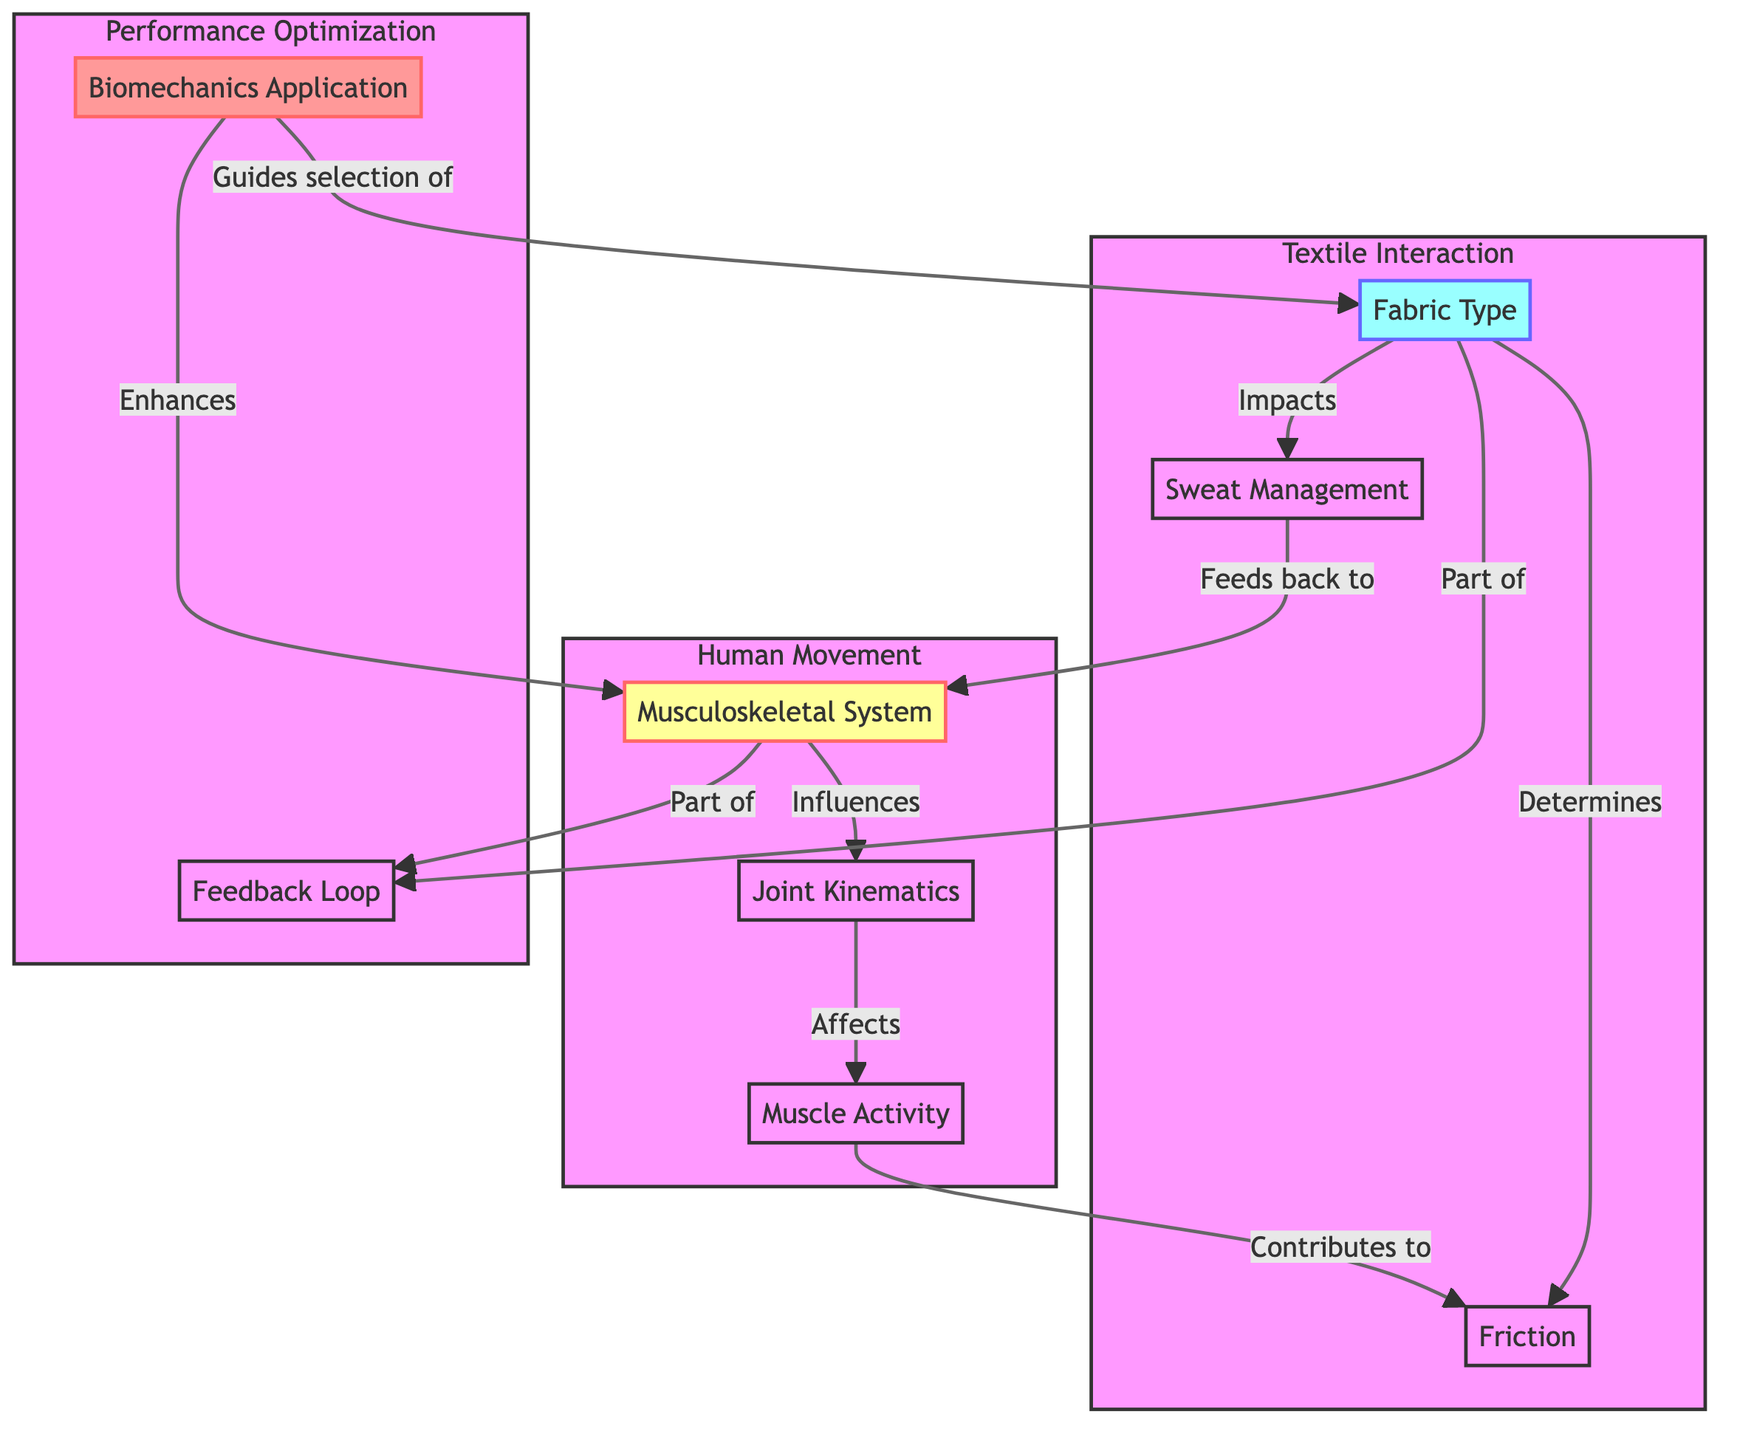What is the main system illustrated in the diagram? The central topic of the diagram is the "Musculoskeletal System," which represents the structure of muscles and bones that facilitate human movement.
Answer: Musculoskeletal System How many nodes represent the textile interaction? There are three nodes specifically related to textile interaction: "Fabric Type," "Friction," and "Sweat Management." Counting these gives a total of three nodes.
Answer: 3 Which node is affected by "Joint Kinematics"? "Muscle Activity" is directly affected by "Joint Kinematics," as depicted by the arrow showing influence in that direction.
Answer: Muscle Activity What is influenced by "Musculoskeletal System"? "Joint Kinematics" is influenced as it arises from the structure and functionality of the musculoskeletal system in human movement.
Answer: Joint Kinematics What role does "Biomechanics Application" play in fabric selection? "Biomechanics Application" guides the selection of "Fabric Type," indicating its critical role in choosing materials for performance wear.
Answer: Guides selection of Fabric Type How does "Sweat Management" relate to the "Musculoskeletal System"? "Sweat Management" feeds back to the "Musculoskeletal System," suggesting it's part of a feedback loop that helps maintain system efficiency during movement.
Answer: Feeds back to Musculoskeletal System What determines "Friction" in this diagram? "Fabric Type" determines "Friction," highlighting the importance of material characteristics in affecting how fabrics perform during movement.
Answer: Fabric Type Explain the relationship between "Muscle Activity" and "Friction". "Muscle Activity" contributes to "Friction," meaning that the way muscles operate during movement affects the resistance encountered between fabrics and skin.
Answer: Contributes to Friction What overall process is represented by the "Feedback Loop"? The "Feedback Loop" incorporates both the "Musculoskeletal System" and "Fabric Type," illustrating how these systems interact dynamically to optimize performance.
Answer: Part of Feedback Loop 